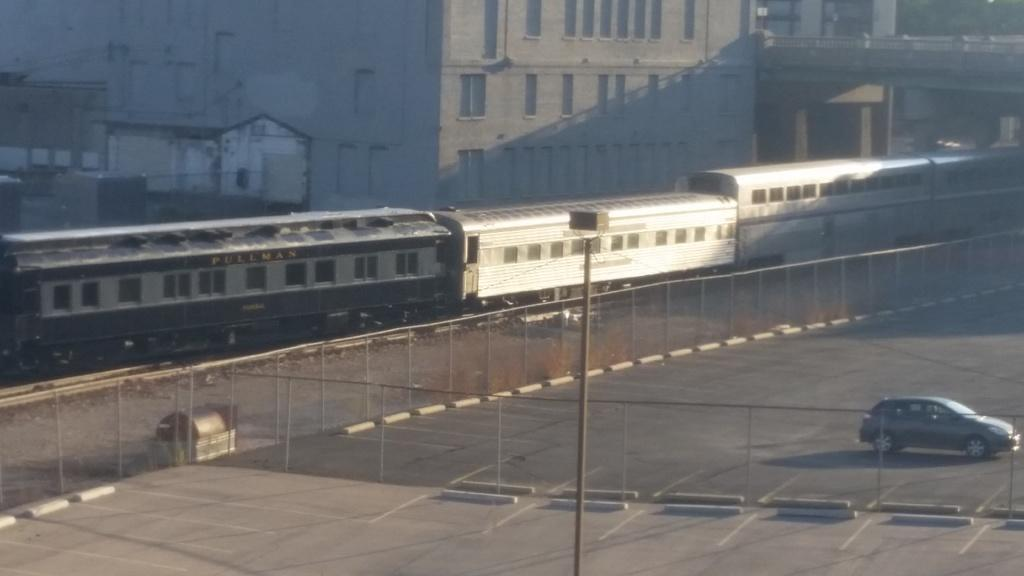What type of vehicle can be seen in the bottom right corner of the image? There is a car in the bottom right corner of the image. What is located in the middle of the image? There is a pole in the middle of the image. What mode of transportation is moving from left to right in the image? There is a train moving from left to right in the image. What type of creature is sitting on top of the train in the image? There is no creature present on top of the train in the image. What color is the gold coin on the pole in the image? There is no gold coin on the pole in the image. 